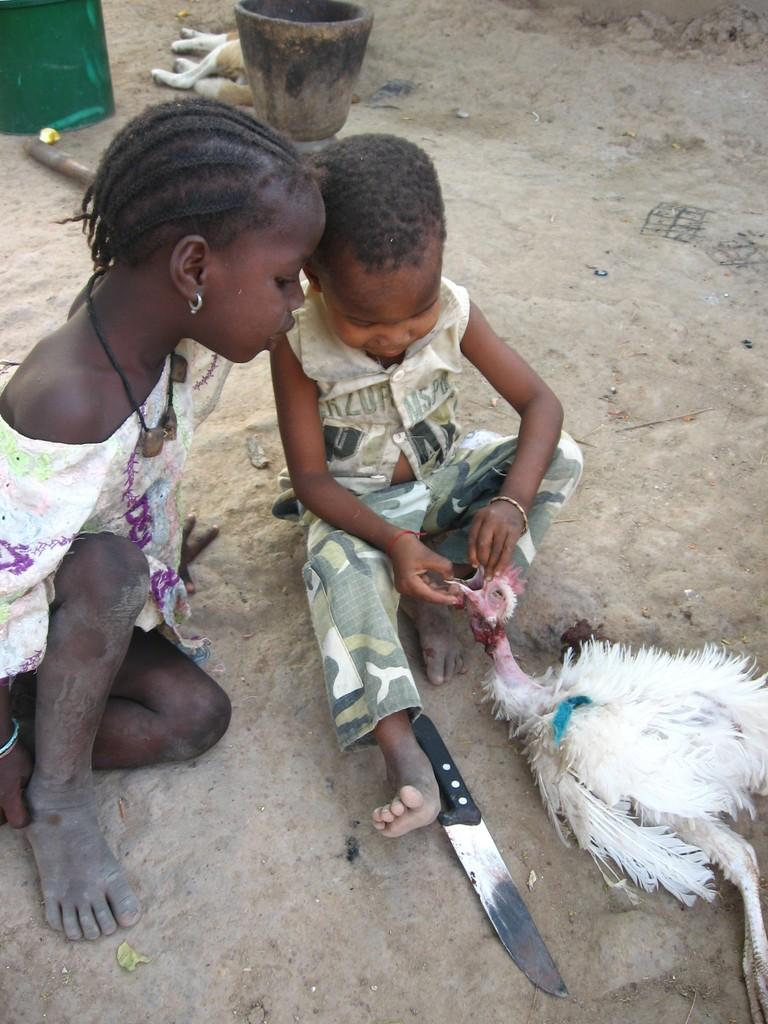How many children are sitting on the sand in the image? There are two children sitting on the sand in the image. What is one of the children holding? One child is holding a hen. What object can be seen at the front of the image? There is a knife at the front of the image. What animal is present behind the children? There is a dog behind the children. What other objects can be seen behind the children? There are other objects visible behind the children. What type of lock is visible on the hen in the image? There is no lock visible on the hen in the image. 